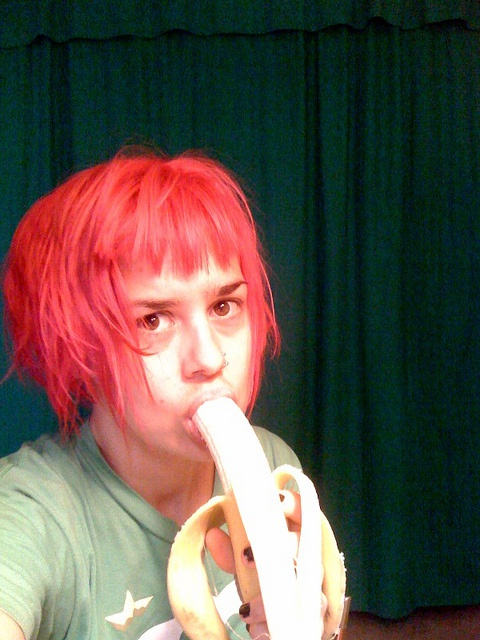Describe the objects in this image and their specific colors. I can see people in black, salmon, beige, red, and darkgray tones and banana in black, white, salmon, and tan tones in this image. 